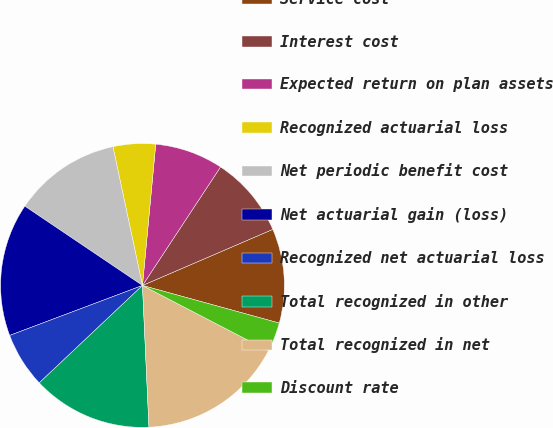Convert chart to OTSL. <chart><loc_0><loc_0><loc_500><loc_500><pie_chart><fcel>Service cost<fcel>Interest cost<fcel>Expected return on plan assets<fcel>Recognized actuarial loss<fcel>Net periodic benefit cost<fcel>Net actuarial gain (loss)<fcel>Recognized net actuarial loss<fcel>Total recognized in other<fcel>Total recognized in net<fcel>Discount rate<nl><fcel>10.74%<fcel>9.26%<fcel>7.78%<fcel>4.83%<fcel>12.22%<fcel>15.17%<fcel>6.31%<fcel>13.69%<fcel>16.65%<fcel>3.35%<nl></chart> 